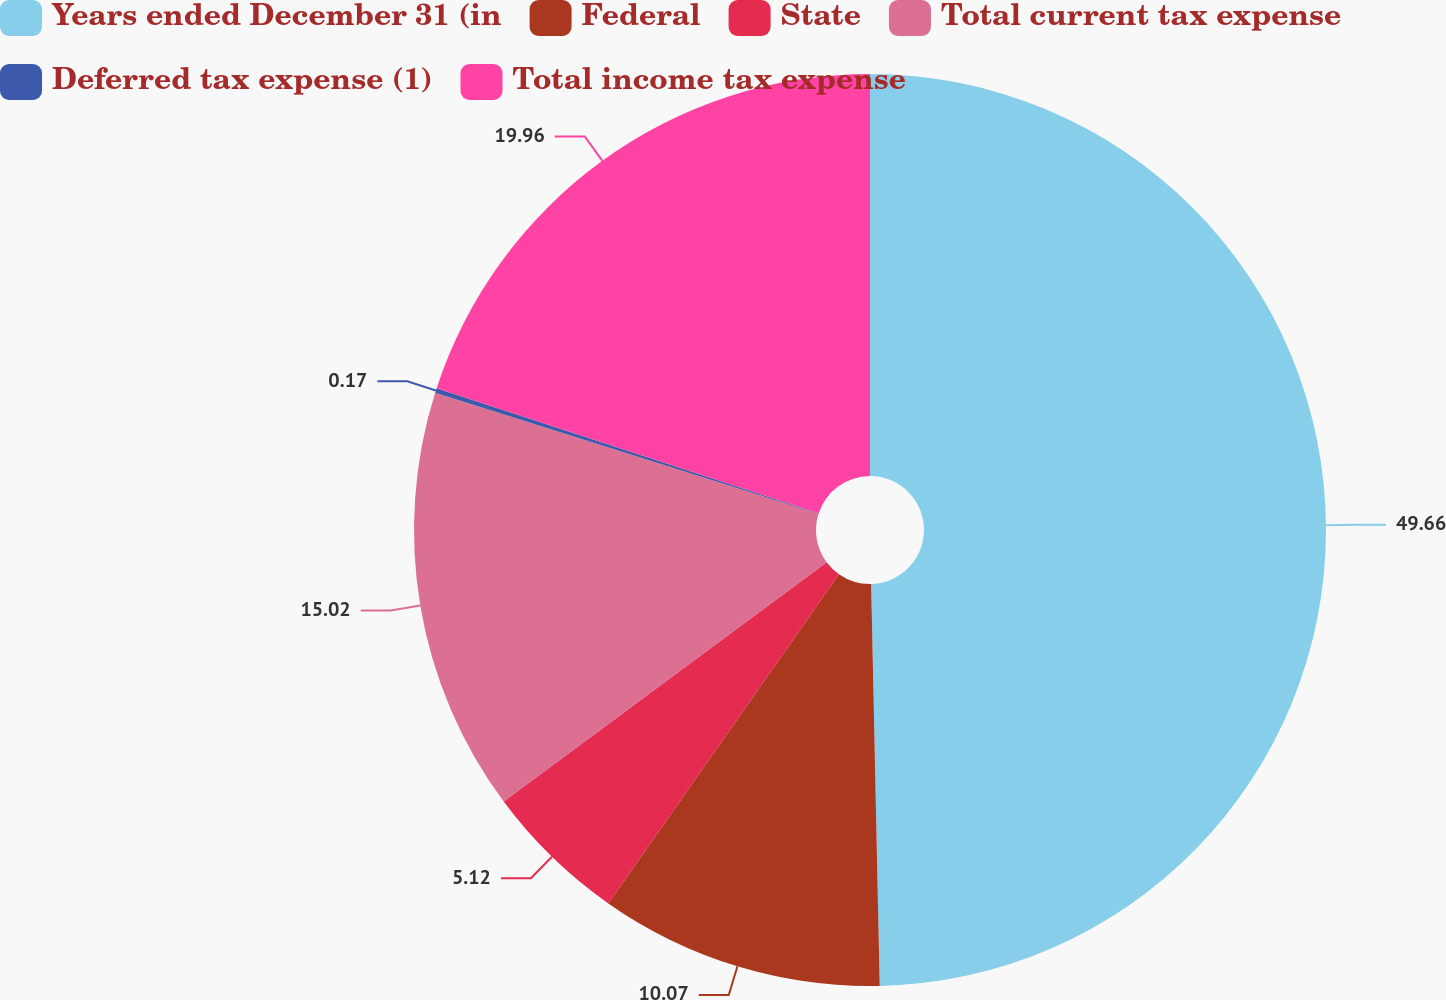Convert chart to OTSL. <chart><loc_0><loc_0><loc_500><loc_500><pie_chart><fcel>Years ended December 31 (in<fcel>Federal<fcel>State<fcel>Total current tax expense<fcel>Deferred tax expense (1)<fcel>Total income tax expense<nl><fcel>49.67%<fcel>10.07%<fcel>5.12%<fcel>15.02%<fcel>0.17%<fcel>19.97%<nl></chart> 